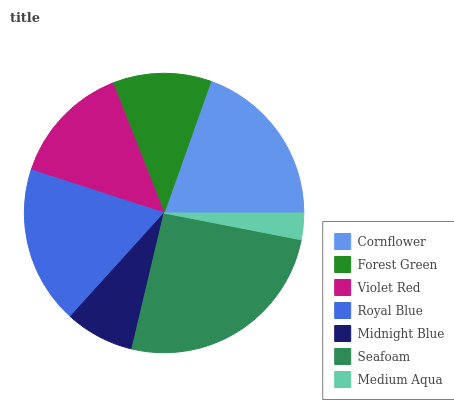Is Medium Aqua the minimum?
Answer yes or no. Yes. Is Seafoam the maximum?
Answer yes or no. Yes. Is Forest Green the minimum?
Answer yes or no. No. Is Forest Green the maximum?
Answer yes or no. No. Is Cornflower greater than Forest Green?
Answer yes or no. Yes. Is Forest Green less than Cornflower?
Answer yes or no. Yes. Is Forest Green greater than Cornflower?
Answer yes or no. No. Is Cornflower less than Forest Green?
Answer yes or no. No. Is Violet Red the high median?
Answer yes or no. Yes. Is Violet Red the low median?
Answer yes or no. Yes. Is Medium Aqua the high median?
Answer yes or no. No. Is Royal Blue the low median?
Answer yes or no. No. 